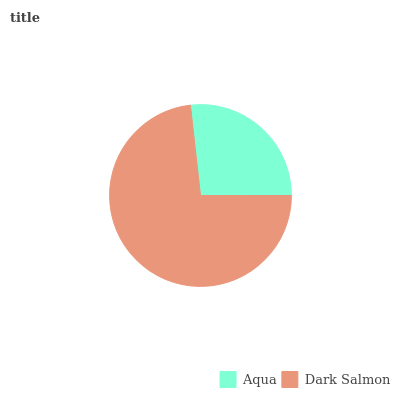Is Aqua the minimum?
Answer yes or no. Yes. Is Dark Salmon the maximum?
Answer yes or no. Yes. Is Dark Salmon the minimum?
Answer yes or no. No. Is Dark Salmon greater than Aqua?
Answer yes or no. Yes. Is Aqua less than Dark Salmon?
Answer yes or no. Yes. Is Aqua greater than Dark Salmon?
Answer yes or no. No. Is Dark Salmon less than Aqua?
Answer yes or no. No. Is Dark Salmon the high median?
Answer yes or no. Yes. Is Aqua the low median?
Answer yes or no. Yes. Is Aqua the high median?
Answer yes or no. No. Is Dark Salmon the low median?
Answer yes or no. No. 